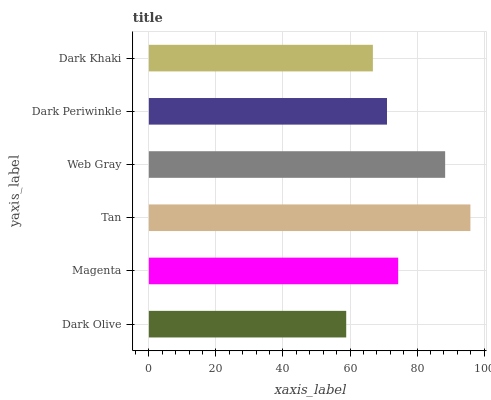Is Dark Olive the minimum?
Answer yes or no. Yes. Is Tan the maximum?
Answer yes or no. Yes. Is Magenta the minimum?
Answer yes or no. No. Is Magenta the maximum?
Answer yes or no. No. Is Magenta greater than Dark Olive?
Answer yes or no. Yes. Is Dark Olive less than Magenta?
Answer yes or no. Yes. Is Dark Olive greater than Magenta?
Answer yes or no. No. Is Magenta less than Dark Olive?
Answer yes or no. No. Is Magenta the high median?
Answer yes or no. Yes. Is Dark Periwinkle the low median?
Answer yes or no. Yes. Is Dark Periwinkle the high median?
Answer yes or no. No. Is Tan the low median?
Answer yes or no. No. 